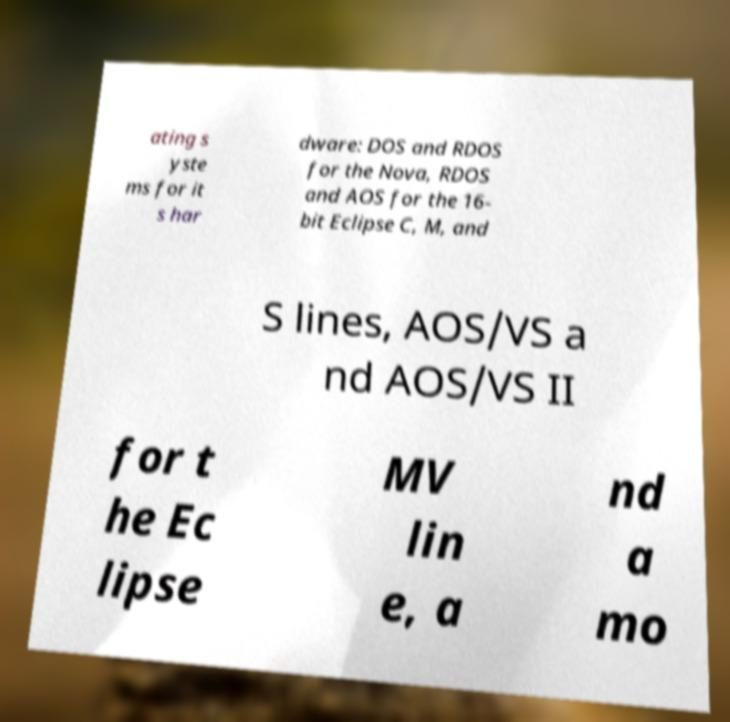Please identify and transcribe the text found in this image. ating s yste ms for it s har dware: DOS and RDOS for the Nova, RDOS and AOS for the 16- bit Eclipse C, M, and S lines, AOS/VS a nd AOS/VS II for t he Ec lipse MV lin e, a nd a mo 